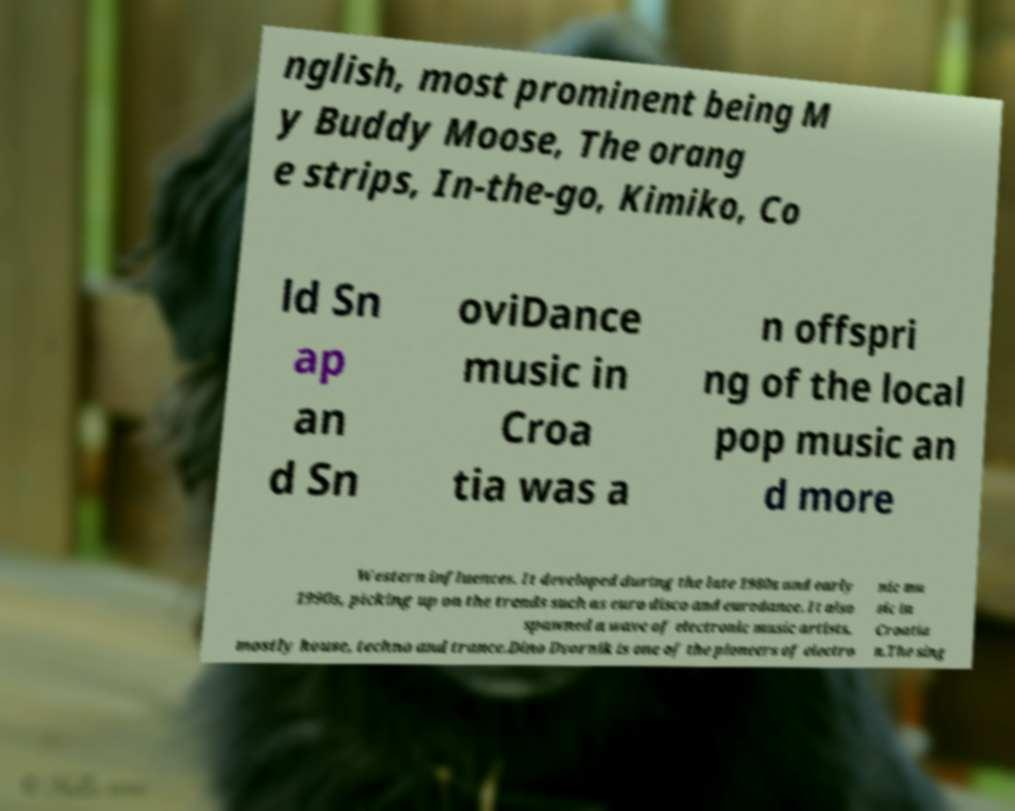There's text embedded in this image that I need extracted. Can you transcribe it verbatim? nglish, most prominent being M y Buddy Moose, The orang e strips, In-the-go, Kimiko, Co ld Sn ap an d Sn oviDance music in Croa tia was a n offspri ng of the local pop music an d more Western influences. It developed during the late 1980s and early 1990s, picking up on the trends such as euro disco and eurodance. It also spawned a wave of electronic music artists, mostly house, techno and trance.Dino Dvornik is one of the pioneers of electro nic mu sic in Croatia n.The sing 